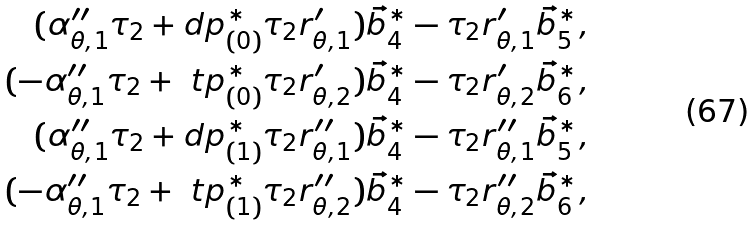Convert formula to latex. <formula><loc_0><loc_0><loc_500><loc_500>( \alpha _ { \theta , 1 } ^ { \prime \prime } \tau _ { 2 } + \i d p _ { ( 0 ) } ^ { \ast } \tau _ { 2 } r _ { \theta , 1 } ^ { \prime } ) \vec { b } _ { 4 } ^ { \ast } - \tau _ { 2 } r _ { \theta , 1 } ^ { \prime } \vec { b } _ { 5 } ^ { \ast } , \\ ( - \alpha _ { \theta , 1 } ^ { \prime \prime } \tau _ { 2 } + \ t p _ { ( 0 ) } ^ { \ast } \tau _ { 2 } r _ { \theta , 2 } ^ { \prime } ) \vec { b } _ { 4 } ^ { \ast } - \tau _ { 2 } r _ { \theta , 2 } ^ { \prime } \vec { b } _ { 6 } ^ { \ast } , \\ ( \alpha _ { \theta , 1 } ^ { \prime \prime } \tau _ { 2 } + \i d p _ { ( 1 ) } ^ { \ast } \tau _ { 2 } r _ { \theta , 1 } ^ { \prime \prime } ) \vec { b } _ { 4 } ^ { \ast } - \tau _ { 2 } r _ { \theta , 1 } ^ { \prime \prime } \vec { b } _ { 5 } ^ { \ast } , \\ ( - \alpha _ { \theta , 1 } ^ { \prime \prime } \tau _ { 2 } + \ t p _ { ( 1 ) } ^ { \ast } \tau _ { 2 } r _ { \theta , 2 } ^ { \prime \prime } ) \vec { b } _ { 4 } ^ { \ast } - \tau _ { 2 } r _ { \theta , 2 } ^ { \prime \prime } \vec { b } _ { 6 } ^ { \ast } ,</formula> 